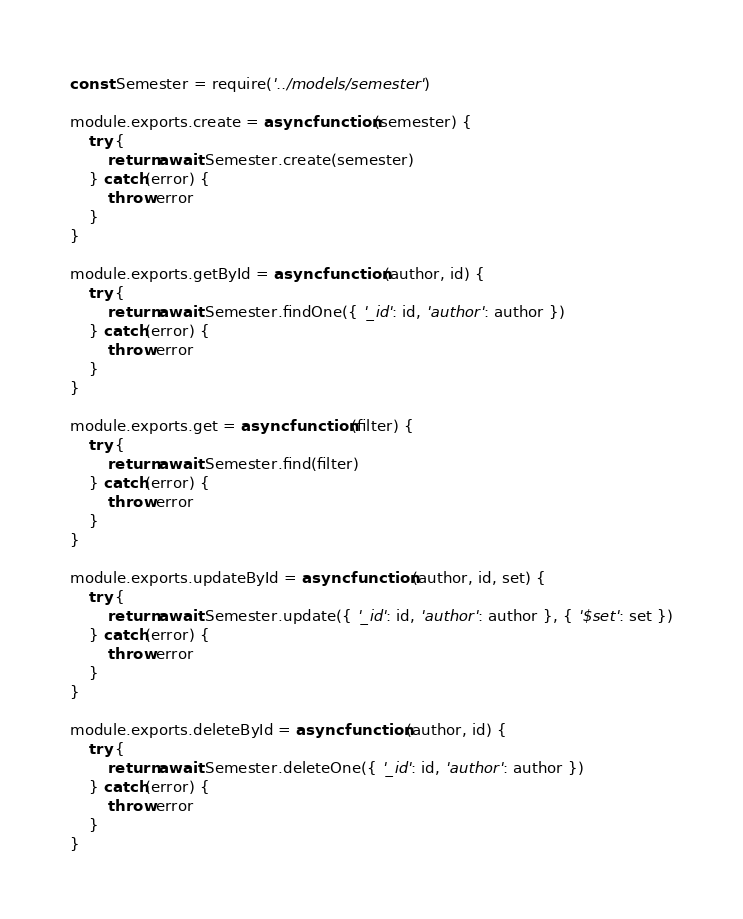<code> <loc_0><loc_0><loc_500><loc_500><_JavaScript_>const Semester = require('../models/semester')

module.exports.create = async function(semester) {
    try {
        return await Semester.create(semester)
    } catch(error) {
        throw error
    }
}

module.exports.getById = async function(author, id) {
    try {
        return await Semester.findOne({ '_id': id, 'author': author })
    } catch(error) {
        throw error
    }
}

module.exports.get = async function(filter) {
    try {
        return await Semester.find(filter)
    } catch(error) {
        throw error
    }
}

module.exports.updateById = async function(author, id, set) {
    try {
        return await Semester.update({ '_id': id, 'author': author }, { '$set': set })
    } catch(error) {
        throw error
    }
}

module.exports.deleteById = async function(author, id) {
    try {
        return await Semester.deleteOne({ '_id': id, 'author': author })
    } catch(error) {
        throw error
    }
}</code> 